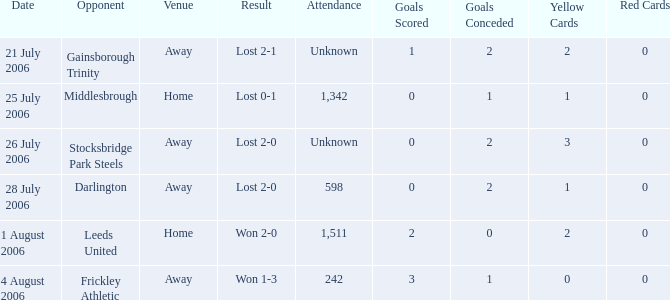Write the full table. {'header': ['Date', 'Opponent', 'Venue', 'Result', 'Attendance', 'Goals Scored', 'Goals Conceded', 'Yellow Cards', 'Red Cards'], 'rows': [['21 July 2006', 'Gainsborough Trinity', 'Away', 'Lost 2-1', 'Unknown', '1', '2', '2', '0'], ['25 July 2006', 'Middlesbrough', 'Home', 'Lost 0-1', '1,342', '0', '1', '1', '0'], ['26 July 2006', 'Stocksbridge Park Steels', 'Away', 'Lost 2-0', 'Unknown', '0', '2', '3', '0'], ['28 July 2006', 'Darlington', 'Away', 'Lost 2-0', '598', '0', '2', '1', '0'], ['1 August 2006', 'Leeds United', 'Home', 'Won 2-0', '1,511', '2', '0', '2', '0'], ['4 August 2006', 'Frickley Athletic', 'Away', 'Won 1-3', '242', '3', '1', '0', '0']]} Which opponent has unknown attendance, and lost 2-0? Stocksbridge Park Steels. 